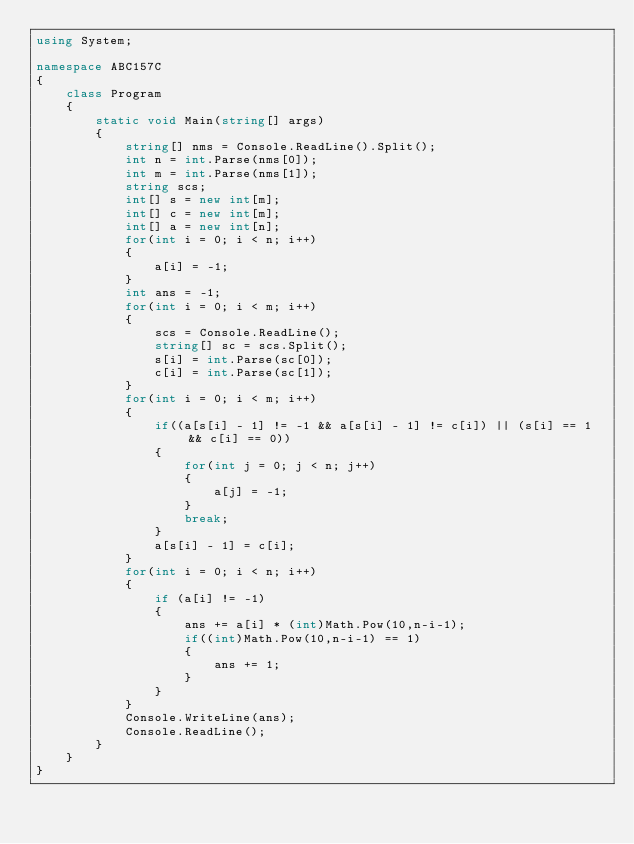Convert code to text. <code><loc_0><loc_0><loc_500><loc_500><_C#_>using System;

namespace ABC157C
{
    class Program
    {
        static void Main(string[] args)
        {
            string[] nms = Console.ReadLine().Split();
            int n = int.Parse(nms[0]);
            int m = int.Parse(nms[1]);
            string scs;
            int[] s = new int[m];
            int[] c = new int[m];
            int[] a = new int[n];
            for(int i = 0; i < n; i++)
            {
                a[i] = -1;
            }
            int ans = -1;
            for(int i = 0; i < m; i++)
            {
                scs = Console.ReadLine();
                string[] sc = scs.Split();
                s[i] = int.Parse(sc[0]);
                c[i] = int.Parse(sc[1]);
            }
            for(int i = 0; i < m; i++)
            {
                if((a[s[i] - 1] != -1 && a[s[i] - 1] != c[i]) || (s[i] == 1 && c[i] == 0))
                {
                    for(int j = 0; j < n; j++)
                    {
                        a[j] = -1;
                    }
                    break;
                }
                a[s[i] - 1] = c[i];
            }
            for(int i = 0; i < n; i++)
            {
                if (a[i] != -1)
                {
                    ans += a[i] * (int)Math.Pow(10,n-i-1);
                    if((int)Math.Pow(10,n-i-1) == 1)
                    {
                        ans += 1;
                    }
                }
            }
            Console.WriteLine(ans);
            Console.ReadLine();
        }
    }
}
</code> 